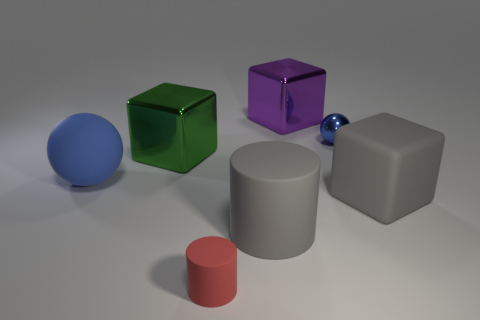Is the shape of the big green metal object the same as the small red thing?
Provide a short and direct response. No. Is there any other thing that has the same size as the gray block?
Offer a terse response. Yes. What number of big gray rubber cylinders are behind the large green metal block?
Provide a succinct answer. 0. Does the blue ball in front of the green shiny block have the same size as the red rubber object?
Give a very brief answer. No. There is another large matte object that is the same shape as the green thing; what color is it?
Your answer should be very brief. Gray. Is there anything else that is the same shape as the small red rubber thing?
Make the answer very short. Yes. What is the shape of the tiny object on the left side of the gray cylinder?
Make the answer very short. Cylinder. What number of large cyan objects have the same shape as the small rubber thing?
Provide a succinct answer. 0. Do the small object in front of the gray cube and the large block that is in front of the large blue matte ball have the same color?
Keep it short and to the point. No. How many objects are big blue shiny cylinders or rubber cylinders?
Offer a terse response. 2. 